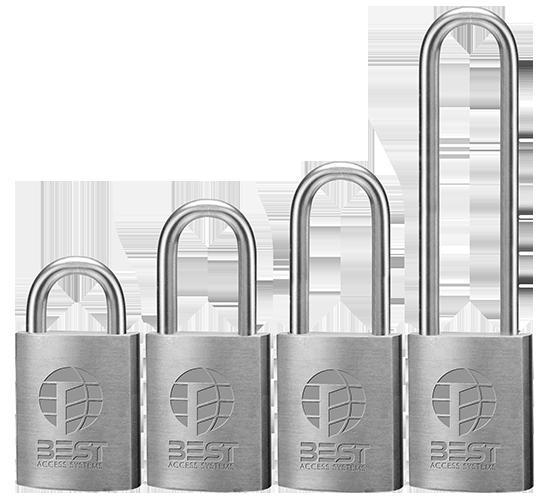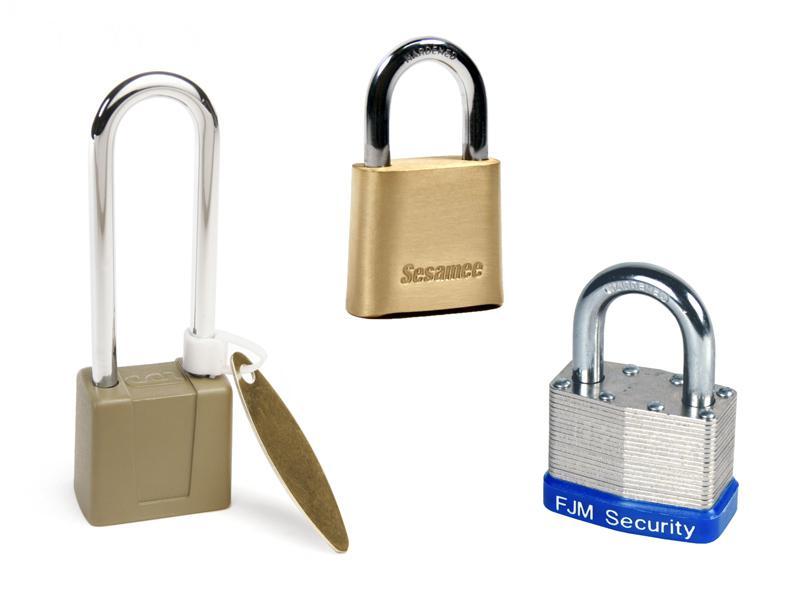The first image is the image on the left, the second image is the image on the right. For the images shown, is this caption "An image includes a gold-colored lock with a loop taller than the body of the lock, and no keys present." true? Answer yes or no. Yes. The first image is the image on the left, the second image is the image on the right. Analyze the images presented: Is the assertion "The right image contains a lock with at least two keys." valid? Answer yes or no. No. 